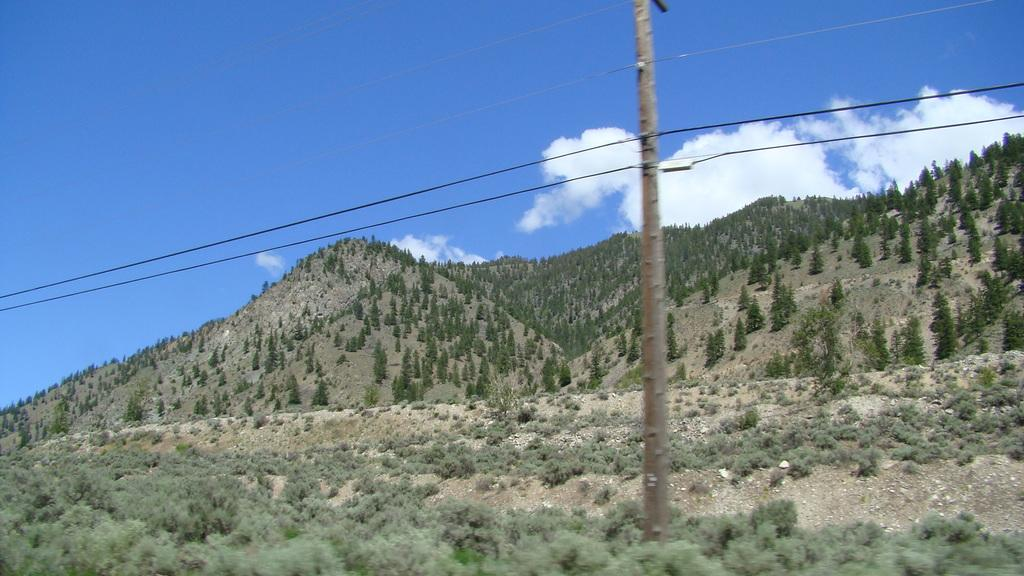What can be seen in the foreground of the picture? In the foreground of the picture, there are shrubs, soil, a current pole, and cables. What type of vegetation is present in the foreground? Shrubs are present in the foreground of the picture. What is the purpose of the current pole in the foreground? The current pole in the foreground is likely used for providing electricity. What can be seen in the background of the picture? In the background of the picture, there are trees on a hill. How would you describe the weather in the image? The sky is sunny, indicating a clear and likely warm day. Can you see the heart of the current pole in the image? There is no heart present in the image, as the current pole is an inanimate object and does not have a heart. What type of summer clothing is the person wearing in the image? There is no person present in the image, so it is impossible to determine what type of clothing they might be wearing. 